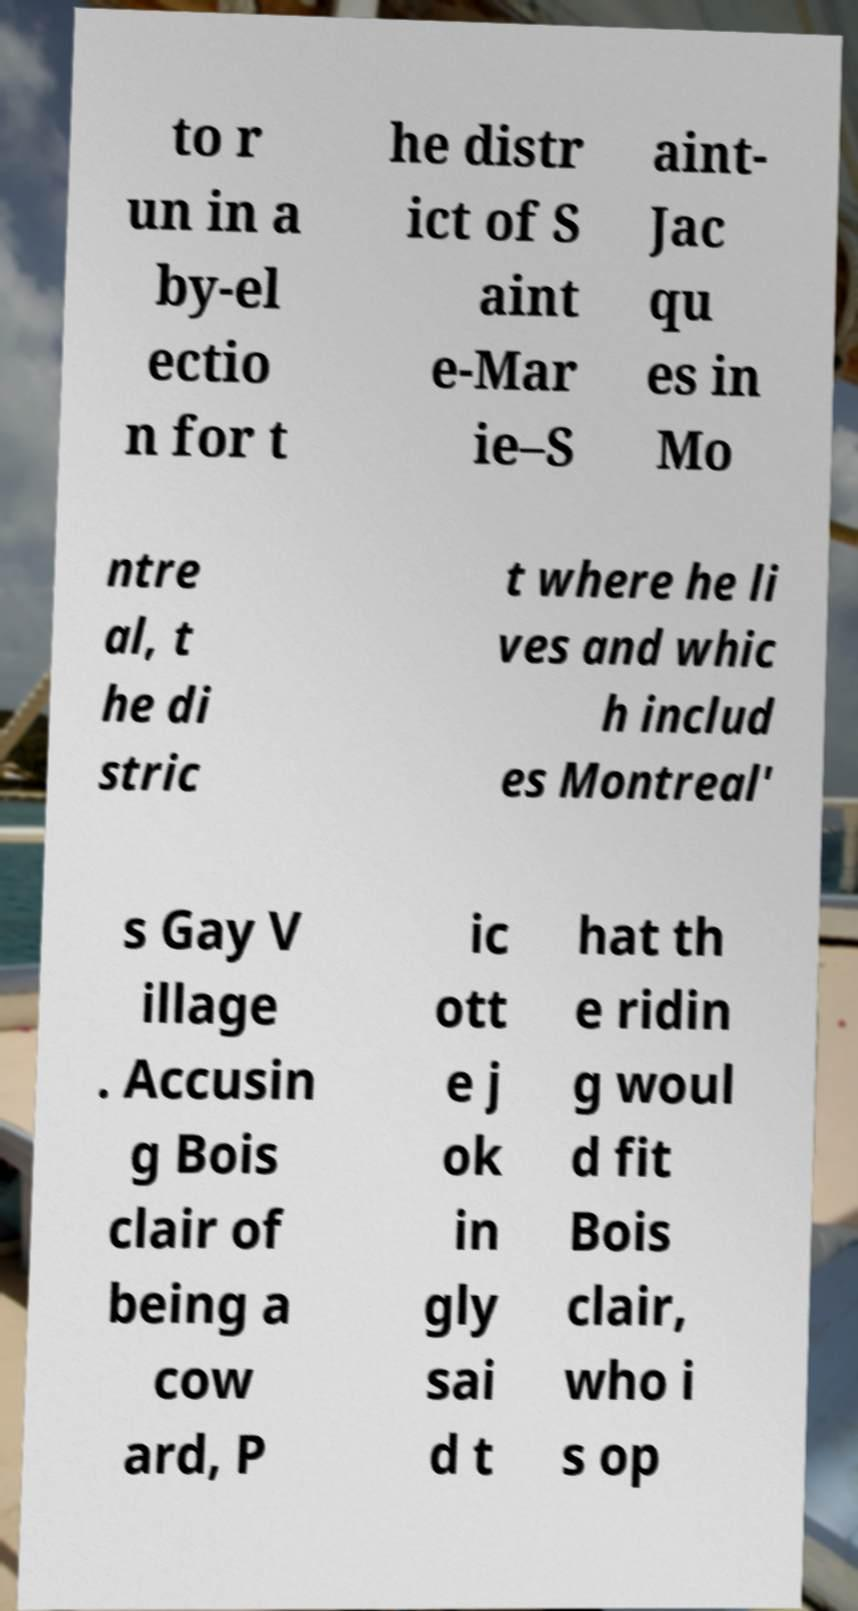Could you extract and type out the text from this image? to r un in a by-el ectio n for t he distr ict of S aint e-Mar ie–S aint- Jac qu es in Mo ntre al, t he di stric t where he li ves and whic h includ es Montreal' s Gay V illage . Accusin g Bois clair of being a cow ard, P ic ott e j ok in gly sai d t hat th e ridin g woul d fit Bois clair, who i s op 